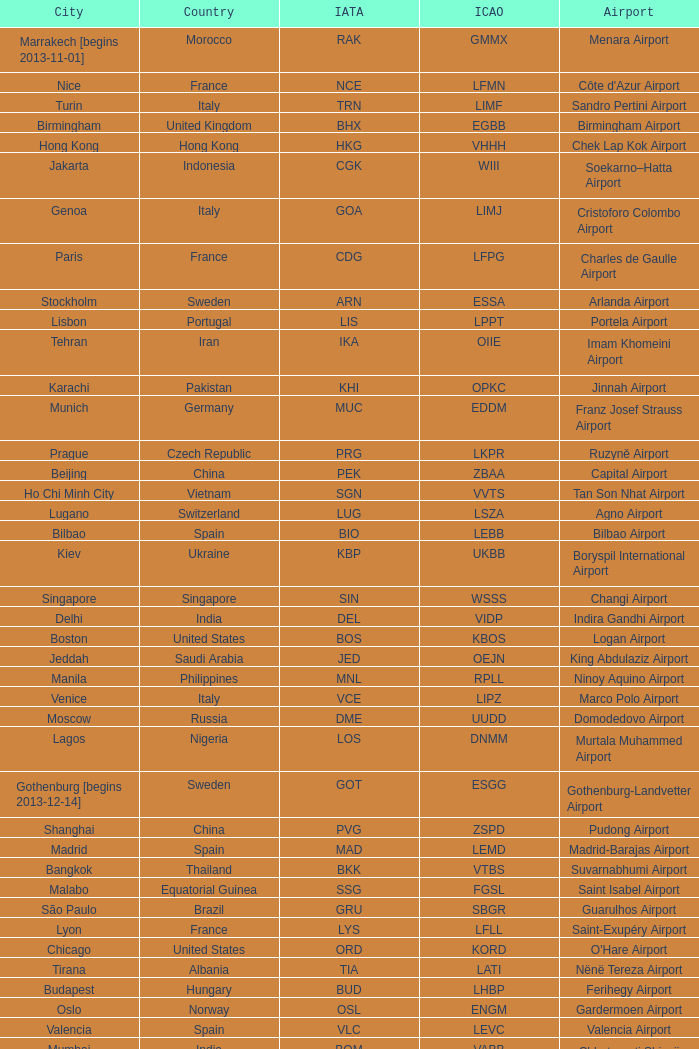What is the ICAO of Douala city? FKKD. 